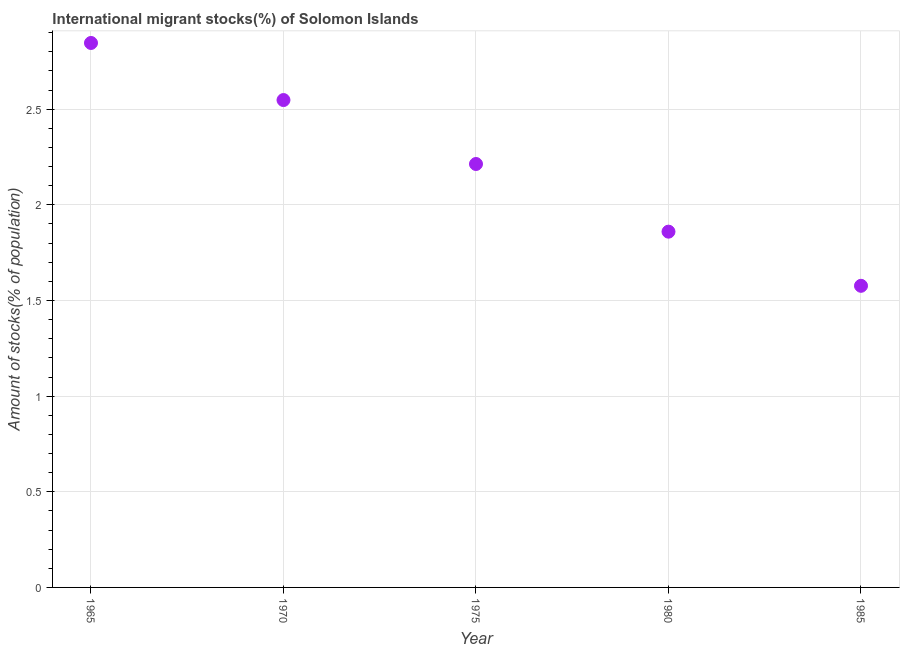What is the number of international migrant stocks in 1985?
Keep it short and to the point. 1.58. Across all years, what is the maximum number of international migrant stocks?
Provide a short and direct response. 2.85. Across all years, what is the minimum number of international migrant stocks?
Provide a succinct answer. 1.58. In which year was the number of international migrant stocks maximum?
Your answer should be very brief. 1965. In which year was the number of international migrant stocks minimum?
Keep it short and to the point. 1985. What is the sum of the number of international migrant stocks?
Offer a very short reply. 11.04. What is the difference between the number of international migrant stocks in 1970 and 1980?
Your answer should be very brief. 0.69. What is the average number of international migrant stocks per year?
Keep it short and to the point. 2.21. What is the median number of international migrant stocks?
Provide a short and direct response. 2.21. Do a majority of the years between 1970 and 1985 (inclusive) have number of international migrant stocks greater than 1.1 %?
Keep it short and to the point. Yes. What is the ratio of the number of international migrant stocks in 1965 to that in 1975?
Give a very brief answer. 1.29. What is the difference between the highest and the second highest number of international migrant stocks?
Your response must be concise. 0.3. Is the sum of the number of international migrant stocks in 1970 and 1980 greater than the maximum number of international migrant stocks across all years?
Keep it short and to the point. Yes. What is the difference between the highest and the lowest number of international migrant stocks?
Make the answer very short. 1.27. How many dotlines are there?
Offer a terse response. 1. What is the difference between two consecutive major ticks on the Y-axis?
Provide a succinct answer. 0.5. Does the graph contain any zero values?
Offer a very short reply. No. What is the title of the graph?
Your answer should be very brief. International migrant stocks(%) of Solomon Islands. What is the label or title of the X-axis?
Provide a short and direct response. Year. What is the label or title of the Y-axis?
Provide a short and direct response. Amount of stocks(% of population). What is the Amount of stocks(% of population) in 1965?
Your response must be concise. 2.85. What is the Amount of stocks(% of population) in 1970?
Your answer should be compact. 2.55. What is the Amount of stocks(% of population) in 1975?
Give a very brief answer. 2.21. What is the Amount of stocks(% of population) in 1980?
Your answer should be compact. 1.86. What is the Amount of stocks(% of population) in 1985?
Your answer should be very brief. 1.58. What is the difference between the Amount of stocks(% of population) in 1965 and 1970?
Your response must be concise. 0.3. What is the difference between the Amount of stocks(% of population) in 1965 and 1975?
Ensure brevity in your answer.  0.63. What is the difference between the Amount of stocks(% of population) in 1965 and 1980?
Provide a succinct answer. 0.99. What is the difference between the Amount of stocks(% of population) in 1965 and 1985?
Your answer should be very brief. 1.27. What is the difference between the Amount of stocks(% of population) in 1970 and 1975?
Give a very brief answer. 0.33. What is the difference between the Amount of stocks(% of population) in 1970 and 1980?
Your answer should be compact. 0.69. What is the difference between the Amount of stocks(% of population) in 1970 and 1985?
Give a very brief answer. 0.97. What is the difference between the Amount of stocks(% of population) in 1975 and 1980?
Provide a succinct answer. 0.35. What is the difference between the Amount of stocks(% of population) in 1975 and 1985?
Provide a succinct answer. 0.64. What is the difference between the Amount of stocks(% of population) in 1980 and 1985?
Offer a terse response. 0.28. What is the ratio of the Amount of stocks(% of population) in 1965 to that in 1970?
Keep it short and to the point. 1.12. What is the ratio of the Amount of stocks(% of population) in 1965 to that in 1975?
Your answer should be very brief. 1.29. What is the ratio of the Amount of stocks(% of population) in 1965 to that in 1980?
Make the answer very short. 1.53. What is the ratio of the Amount of stocks(% of population) in 1965 to that in 1985?
Offer a very short reply. 1.8. What is the ratio of the Amount of stocks(% of population) in 1970 to that in 1975?
Your answer should be very brief. 1.15. What is the ratio of the Amount of stocks(% of population) in 1970 to that in 1980?
Your answer should be compact. 1.37. What is the ratio of the Amount of stocks(% of population) in 1970 to that in 1985?
Keep it short and to the point. 1.62. What is the ratio of the Amount of stocks(% of population) in 1975 to that in 1980?
Provide a succinct answer. 1.19. What is the ratio of the Amount of stocks(% of population) in 1975 to that in 1985?
Offer a very short reply. 1.4. What is the ratio of the Amount of stocks(% of population) in 1980 to that in 1985?
Your response must be concise. 1.18. 